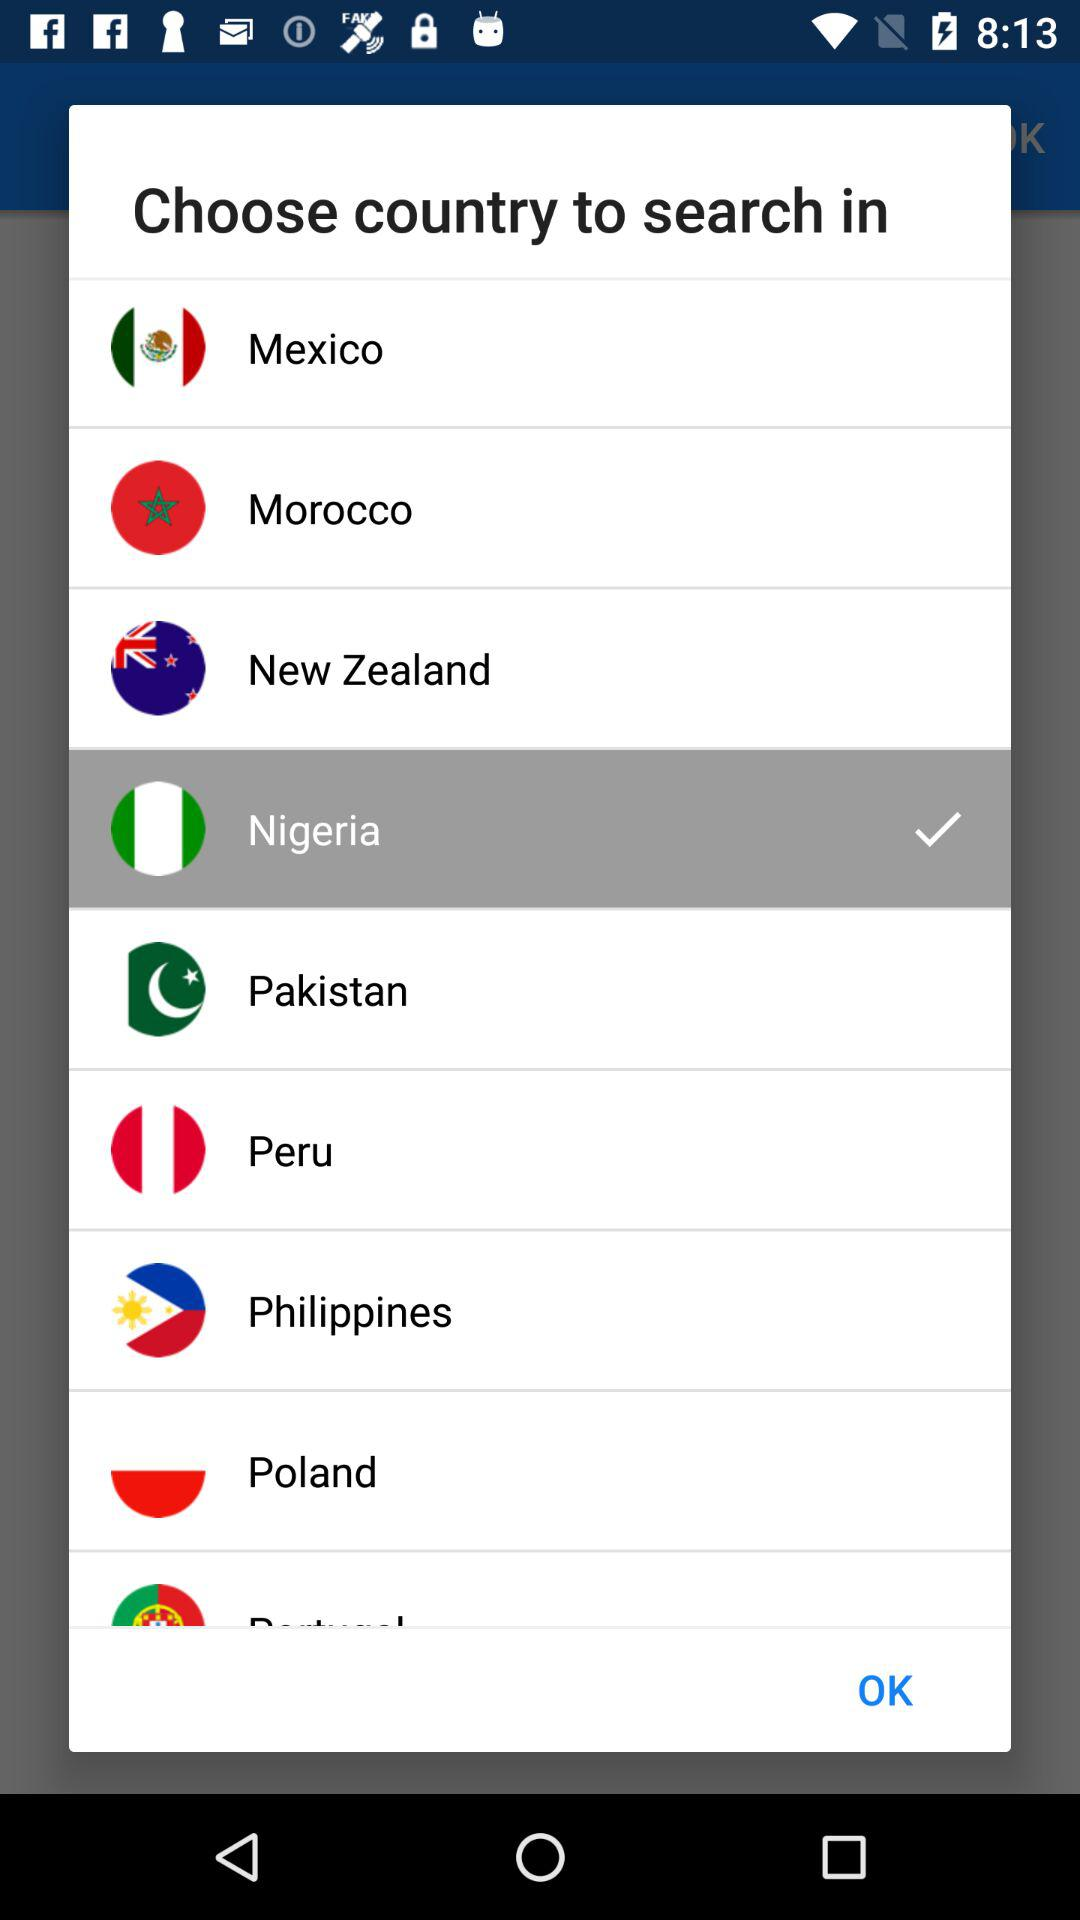How many countries have a checkmark next to them?
Answer the question using a single word or phrase. 1 